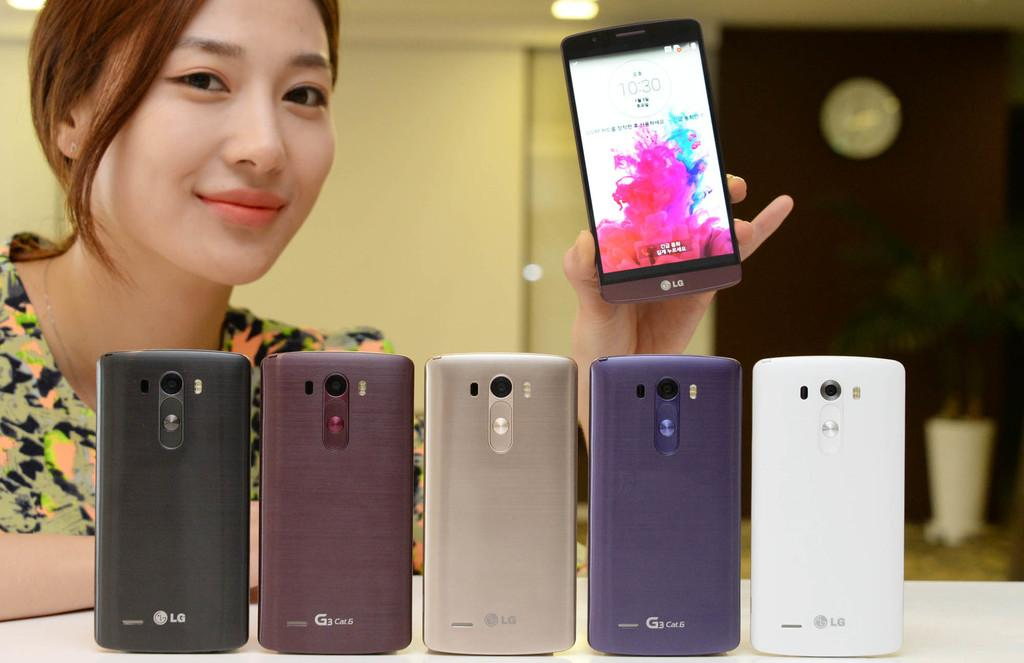<image>
Create a compact narrative representing the image presented. A woman holds on to an LG phone behind five other LG phones in different case colors. 